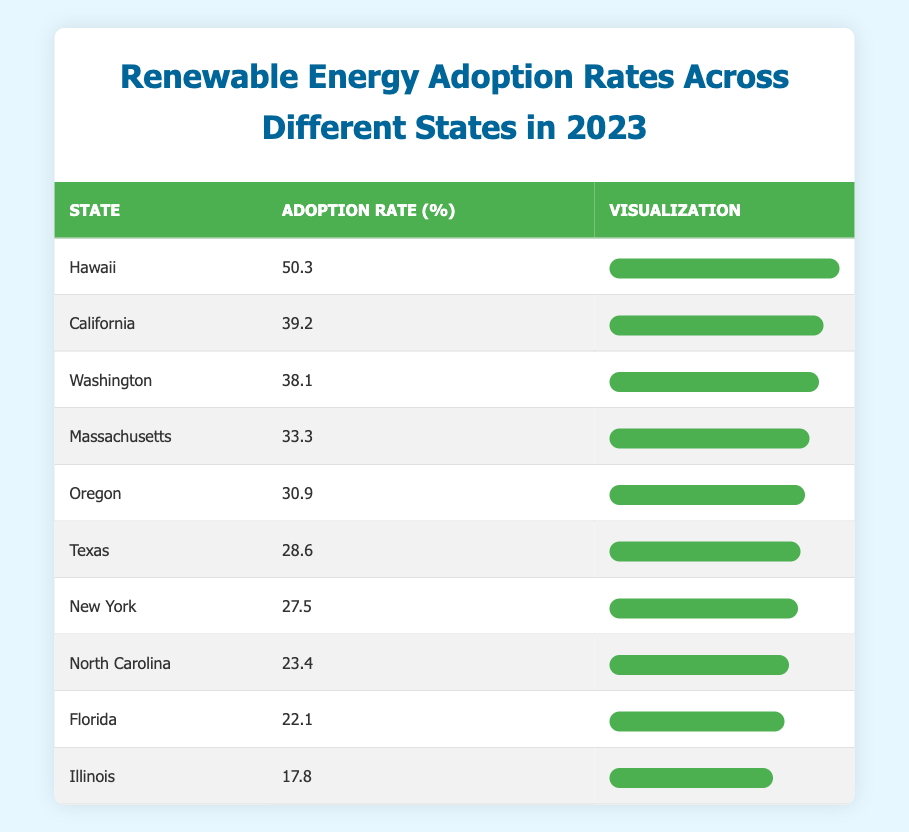What state has the highest renewable energy adoption rate? By reviewing the table, I can see that Hawaii has the highest rate at 50.3%.
Answer: Hawaii What is the adoption rate of California? Referring to the table, California's adoption rate is listed as 39.2%.
Answer: 39.2% Which state has a higher adoption rate, Florida or Illinois? By comparing the two states, Florida has a rate of 22.1% while Illinois has a lower rate of 17.8%. Therefore, Florida has the higher rate.
Answer: Florida What is the average renewable energy adoption rate of the states listed? The adoption rates are: 50.3, 39.2, 38.1, 33.3, 30.9, 28.6, 27.5, 23.4, 22.1, 17.8. Adding these gives a total of  50.3 + 39.2 + 38.1 + 33.3 + 30.9 + 28.6 + 27.5 + 23.4 + 22.1 + 17.8 =  339.8. There are 10 states, so the average rate is 339.8 / 10 = 33.98%.
Answer: 33.98% Does Texas have a renewable energy adoption rate greater than 30%? Texas has an adoption rate of 28.6%, which is less than 30%, so the answer is no.
Answer: No What is the difference in adoption rates between Massachusetts and North Carolina? Massachusetts has an adoption rate of 33.3% and North Carolina has 23.4%. The difference is calculated as 33.3% - 23.4% = 9.9%.
Answer: 9.9% Which state has a lower adoption rate, Oregon or New York? Oregon's adoption rate is 30.9% and New York's is 27.5%. Since 27.5% is less than 30.9%, New York has the lower rate.
Answer: New York Is the adoption rate in Washington greater than the average of the states? Washington's adoption rate is 38.1%. For the average, we calculated as 33.98%. Since 38.1% is greater than 33.98%, the answer is yes.
Answer: Yes 